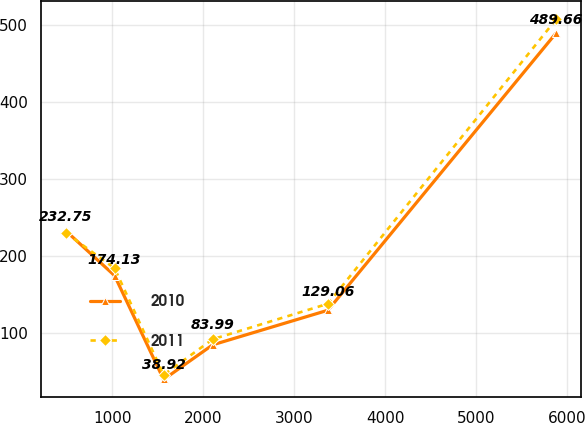<chart> <loc_0><loc_0><loc_500><loc_500><line_chart><ecel><fcel>2010<fcel>2011<nl><fcel>487.57<fcel>232.75<fcel>230<nl><fcel>1026.7<fcel>174.13<fcel>183.75<nl><fcel>1565.83<fcel>38.92<fcel>45<nl><fcel>2104.96<fcel>83.99<fcel>91.25<nl><fcel>3372.14<fcel>129.06<fcel>137.5<nl><fcel>5878.91<fcel>489.66<fcel>507.51<nl></chart> 